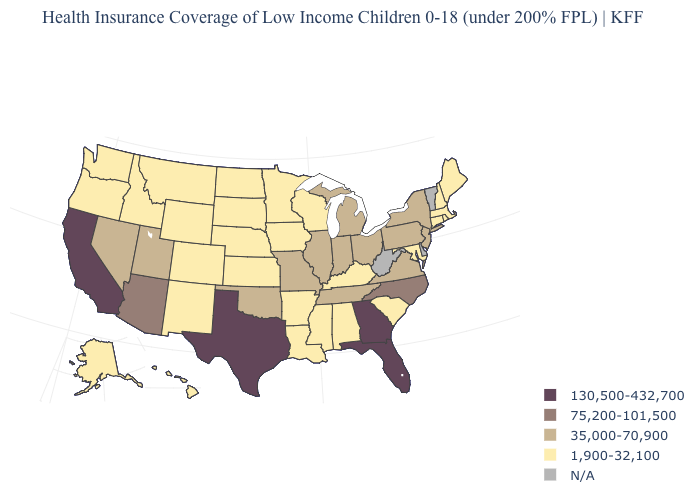Does the map have missing data?
Quick response, please. Yes. Name the states that have a value in the range 1,900-32,100?
Concise answer only. Alabama, Alaska, Arkansas, Colorado, Connecticut, Hawaii, Idaho, Iowa, Kansas, Kentucky, Louisiana, Maine, Maryland, Massachusetts, Minnesota, Mississippi, Montana, Nebraska, New Hampshire, New Mexico, North Dakota, Oregon, Rhode Island, South Carolina, South Dakota, Washington, Wisconsin, Wyoming. What is the highest value in states that border Texas?
Quick response, please. 35,000-70,900. Which states hav the highest value in the MidWest?
Be succinct. Illinois, Indiana, Michigan, Missouri, Ohio. Name the states that have a value in the range 75,200-101,500?
Short answer required. Arizona, North Carolina. Is the legend a continuous bar?
Write a very short answer. No. What is the value of North Carolina?
Answer briefly. 75,200-101,500. Does the map have missing data?
Quick response, please. Yes. Name the states that have a value in the range N/A?
Give a very brief answer. Delaware, Vermont, West Virginia. Does Utah have the lowest value in the USA?
Give a very brief answer. No. How many symbols are there in the legend?
Write a very short answer. 5. Does Arkansas have the lowest value in the USA?
Short answer required. Yes. Name the states that have a value in the range 130,500-432,700?
Keep it brief. California, Florida, Georgia, Texas. What is the value of Montana?
Short answer required. 1,900-32,100. 